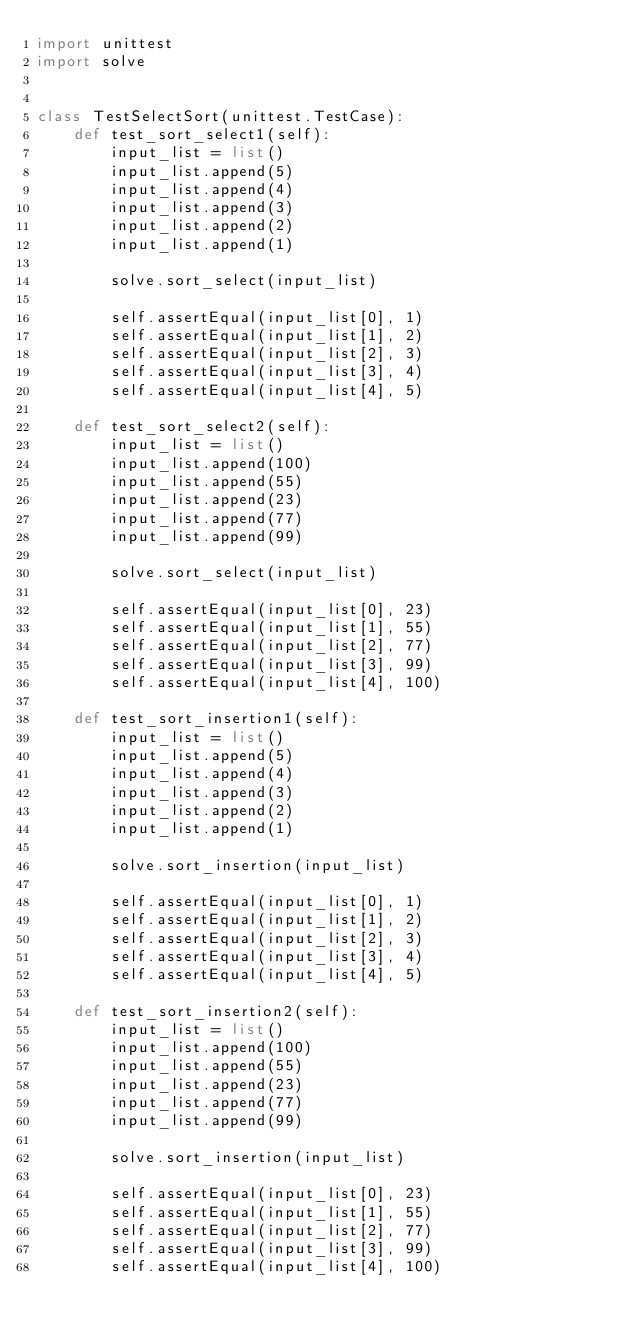Convert code to text. <code><loc_0><loc_0><loc_500><loc_500><_Python_>import unittest
import solve


class TestSelectSort(unittest.TestCase):
    def test_sort_select1(self):
        input_list = list()
        input_list.append(5)
        input_list.append(4)
        input_list.append(3)
        input_list.append(2)
        input_list.append(1)

        solve.sort_select(input_list)

        self.assertEqual(input_list[0], 1)
        self.assertEqual(input_list[1], 2)
        self.assertEqual(input_list[2], 3)
        self.assertEqual(input_list[3], 4)
        self.assertEqual(input_list[4], 5)

    def test_sort_select2(self):
        input_list = list()
        input_list.append(100)
        input_list.append(55)
        input_list.append(23)
        input_list.append(77)
        input_list.append(99)

        solve.sort_select(input_list)

        self.assertEqual(input_list[0], 23)
        self.assertEqual(input_list[1], 55)
        self.assertEqual(input_list[2], 77)
        self.assertEqual(input_list[3], 99)
        self.assertEqual(input_list[4], 100)

    def test_sort_insertion1(self):
        input_list = list()
        input_list.append(5)
        input_list.append(4)
        input_list.append(3)
        input_list.append(2)
        input_list.append(1)

        solve.sort_insertion(input_list)

        self.assertEqual(input_list[0], 1)
        self.assertEqual(input_list[1], 2)
        self.assertEqual(input_list[2], 3)
        self.assertEqual(input_list[3], 4)
        self.assertEqual(input_list[4], 5)

    def test_sort_insertion2(self):
        input_list = list()
        input_list.append(100)
        input_list.append(55)
        input_list.append(23)
        input_list.append(77)
        input_list.append(99)

        solve.sort_insertion(input_list)

        self.assertEqual(input_list[0], 23)
        self.assertEqual(input_list[1], 55)
        self.assertEqual(input_list[2], 77)
        self.assertEqual(input_list[3], 99)
        self.assertEqual(input_list[4], 100)


</code> 